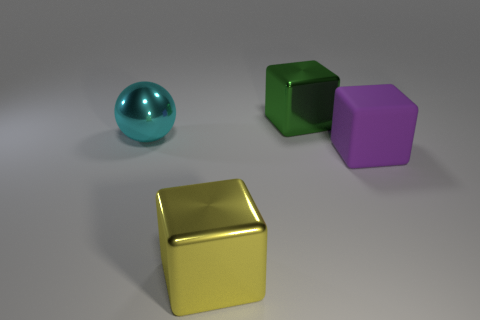There is a big object that is to the left of the metal cube that is left of the green metallic thing; what number of big cyan balls are behind it?
Make the answer very short. 0. Is the number of shiny things that are to the left of the yellow metallic cube the same as the number of small purple matte blocks?
Offer a terse response. No. How many balls are large things or cyan metallic things?
Give a very brief answer. 1. Is the number of large objects in front of the large purple object the same as the number of big blocks in front of the large green object?
Offer a very short reply. No. The large matte block is what color?
Offer a terse response. Purple. How many objects are big objects that are in front of the green thing or large shiny objects?
Offer a very short reply. 4. There is a metal block behind the large yellow cube; is its size the same as the metallic thing in front of the cyan shiny ball?
Keep it short and to the point. Yes. Is there anything else that has the same material as the large purple block?
Your answer should be very brief. No. How many things are either metallic objects that are behind the yellow shiny block or things that are in front of the green thing?
Your answer should be very brief. 4. Are the purple block and the cube behind the large cyan ball made of the same material?
Offer a very short reply. No. 